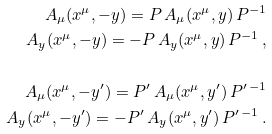<formula> <loc_0><loc_0><loc_500><loc_500>A _ { \mu } ( x ^ { \mu } , - y ) = P \, A _ { \mu } ( x ^ { \mu } , y ) \, P ^ { - 1 } \\ A _ { y } ( x ^ { \mu } , - y ) = - P \, A _ { y } ( x ^ { \mu } , y ) \, P ^ { - 1 } \, , \\ \\ A _ { \mu } ( x ^ { \mu } , - y ^ { \prime } ) = P ^ { \prime } \, A _ { \mu } ( x ^ { \mu } , y ^ { \prime } ) \, P ^ { \prime \, - 1 } \\ A _ { y } ( x ^ { \mu } , - y ^ { \prime } ) = - P ^ { \prime } \, A _ { y } ( x ^ { \mu } , y ^ { \prime } ) \, P ^ { \prime \, - 1 } \, .</formula> 